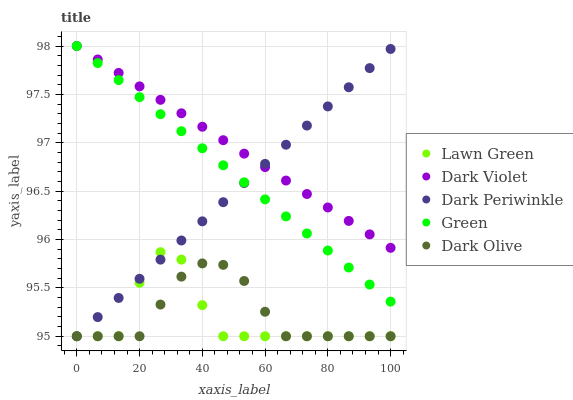Does Lawn Green have the minimum area under the curve?
Answer yes or no. Yes. Does Dark Violet have the maximum area under the curve?
Answer yes or no. Yes. Does Dark Olive have the minimum area under the curve?
Answer yes or no. No. Does Dark Olive have the maximum area under the curve?
Answer yes or no. No. Is Green the smoothest?
Answer yes or no. Yes. Is Lawn Green the roughest?
Answer yes or no. Yes. Is Dark Olive the smoothest?
Answer yes or no. No. Is Dark Olive the roughest?
Answer yes or no. No. Does Lawn Green have the lowest value?
Answer yes or no. Yes. Does Green have the lowest value?
Answer yes or no. No. Does Dark Violet have the highest value?
Answer yes or no. Yes. Does Dark Olive have the highest value?
Answer yes or no. No. Is Lawn Green less than Green?
Answer yes or no. Yes. Is Dark Violet greater than Dark Olive?
Answer yes or no. Yes. Does Dark Periwinkle intersect Dark Olive?
Answer yes or no. Yes. Is Dark Periwinkle less than Dark Olive?
Answer yes or no. No. Is Dark Periwinkle greater than Dark Olive?
Answer yes or no. No. Does Lawn Green intersect Green?
Answer yes or no. No. 